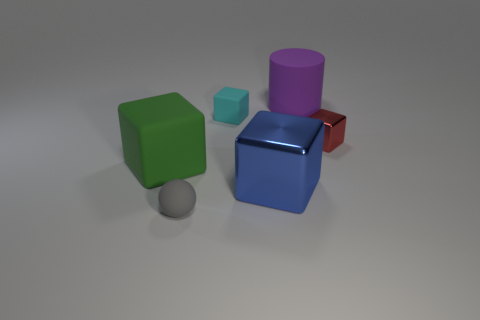Is there any other thing that has the same shape as the small gray matte thing?
Keep it short and to the point. No. Is the shape of the tiny rubber thing behind the gray matte object the same as  the small gray object?
Your answer should be compact. No. Are there more tiny objects in front of the tiny shiny block than small green shiny spheres?
Make the answer very short. Yes. There is a block that is the same size as the blue thing; what color is it?
Your answer should be very brief. Green. How many objects are either tiny red things right of the green cube or tiny blocks?
Offer a very short reply. 2. There is a cube that is right of the big matte object to the right of the small cyan matte object; what is it made of?
Provide a short and direct response. Metal. Is there a tiny cyan cube made of the same material as the red cube?
Ensure brevity in your answer.  No. There is a tiny object in front of the blue thing; is there a matte thing that is behind it?
Give a very brief answer. Yes. What is the material of the cube on the left side of the gray sphere?
Give a very brief answer. Rubber. Is the shape of the tiny red thing the same as the small cyan matte object?
Your response must be concise. Yes. 